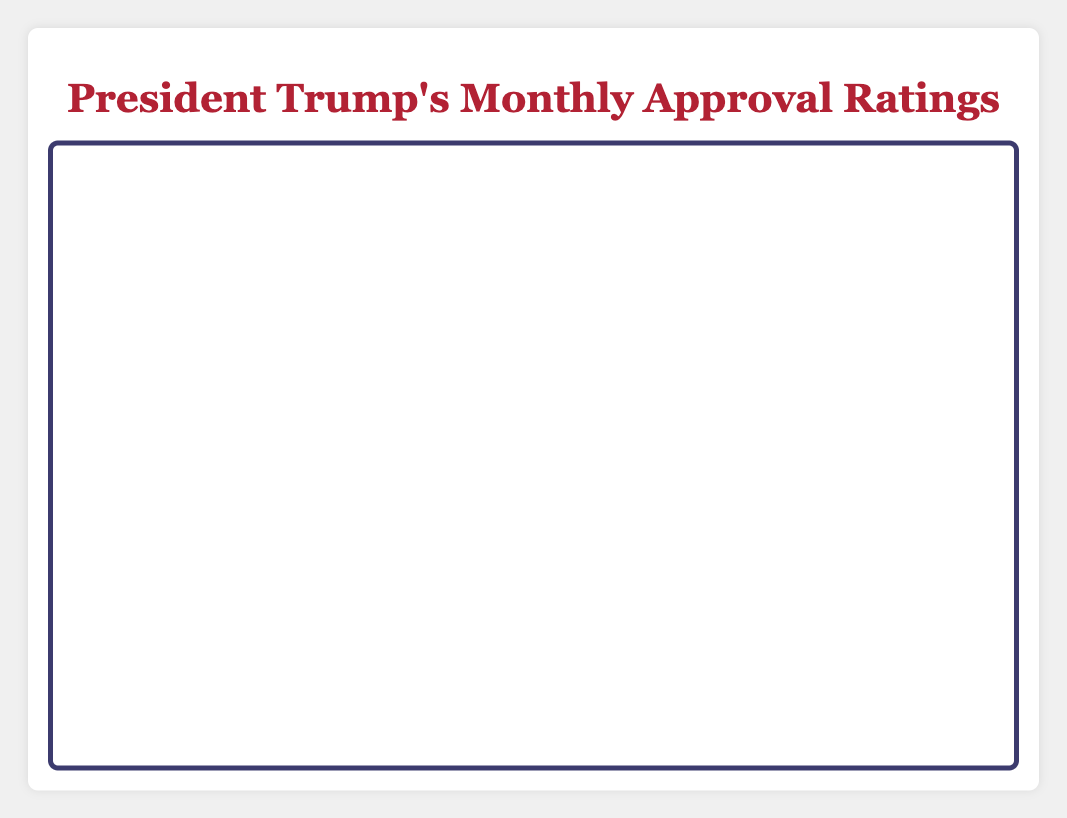What's the highest monthly approval rating for President Trump in the given data? The highest monthly approval rating is shown as the peak on the graph. It appears in November 2016 with an approval rating of 55%.
Answer: 55% What is the lowest monthly approval rating from 2016 to 2020? The lowest point on the line chart represents the lowest approval rating, which is shown in November 2017 with an approval rating of 37%.
Answer: 37% How did the approval rating change from the start of President Trump's term to the end? The approval rating in January 2017 was 45%, and in December 2020, it was 45%. These two points are connected by examining the height of the lines corresponding to these dates.
Answer: It remained the same What is the average approval rating in 2018? Sum of the monthly approval ratings in 2018: 40 + 42 + 41 + 42 + 43 + 42 + 44 + 43 + 42 + 43 + 44 + 42 = 510. Divide by the number of months in a year (12): 510/12 = 42.5.
Answer: 42.5 In which year did the approval rating show the most improvement? Compare the difference between the starting and ending approval ratings for each year. The biggest improvement can be observed from the steepest overall increase in the chart, which occurs in 2020.
Answer: 2020 Which month in 2020 had the highest approval rating? By looking at the highest peak in 2020, March shows the highest approval rating at 47%.
Answer: March How many times did the approval rating cross 40% between 2016 and 2020? Count each time the line crosses the 40% mark, including both upward and downward crossings. Observing the chart depicts these crossings which happen multiple times.
Answer: 7 times What was the trend in approval rating from February 2018 to July 2018? From February 2018 to July 2018, the approval rating increased slightly. It started at 42% in February and peaked at 44% in July.
Answer: It increased Between August 2019 and February 2020, did the approval rating increase, decrease, or stay the same? Checking sequential monthly points from August 2019 (43%) to February 2020 (45%) reveals a slight increase.
Answer: It increased What month in 2017 shows a significant drop in approval rating compared to the previous months? Between January 2017 (45%) and February 2017 (44%), the line begins a downward trend. The drop continues notably until April 2017.
Answer: April 